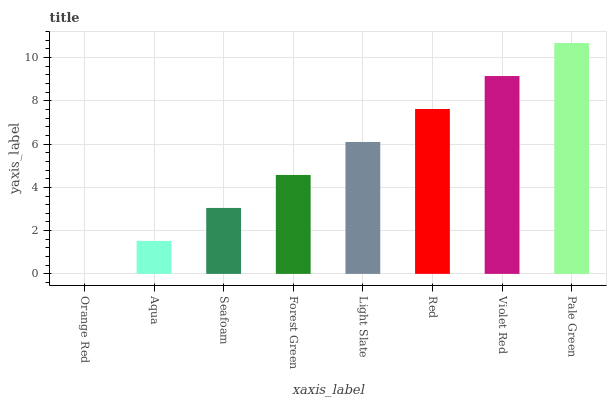Is Orange Red the minimum?
Answer yes or no. Yes. Is Pale Green the maximum?
Answer yes or no. Yes. Is Aqua the minimum?
Answer yes or no. No. Is Aqua the maximum?
Answer yes or no. No. Is Aqua greater than Orange Red?
Answer yes or no. Yes. Is Orange Red less than Aqua?
Answer yes or no. Yes. Is Orange Red greater than Aqua?
Answer yes or no. No. Is Aqua less than Orange Red?
Answer yes or no. No. Is Light Slate the high median?
Answer yes or no. Yes. Is Forest Green the low median?
Answer yes or no. Yes. Is Red the high median?
Answer yes or no. No. Is Seafoam the low median?
Answer yes or no. No. 